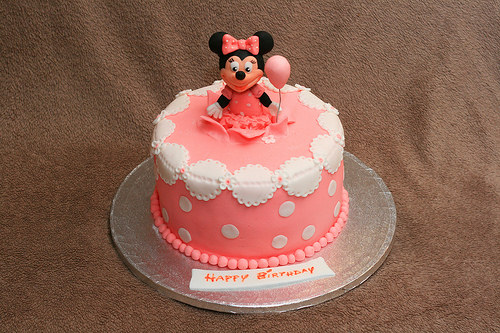<image>
Can you confirm if the mini mouse is on the cake? Yes. Looking at the image, I can see the mini mouse is positioned on top of the cake, with the cake providing support. Is the doll on the cake? Yes. Looking at the image, I can see the doll is positioned on top of the cake, with the cake providing support. 